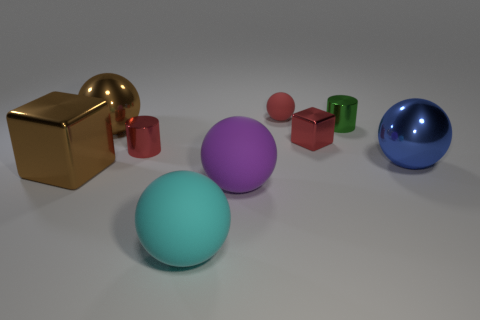Subtract all big brown metal balls. How many balls are left? 4 Subtract all red spheres. How many spheres are left? 4 Subtract all gray balls. Subtract all yellow cylinders. How many balls are left? 5 Add 1 matte spheres. How many objects exist? 10 Subtract all balls. How many objects are left? 4 Add 9 big blue things. How many big blue things are left? 10 Add 6 tiny red cylinders. How many tiny red cylinders exist? 7 Subtract 0 gray cylinders. How many objects are left? 9 Subtract all large blue shiny balls. Subtract all large cyan rubber objects. How many objects are left? 7 